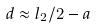Convert formula to latex. <formula><loc_0><loc_0><loc_500><loc_500>d \approx l _ { 2 } / 2 - a</formula> 